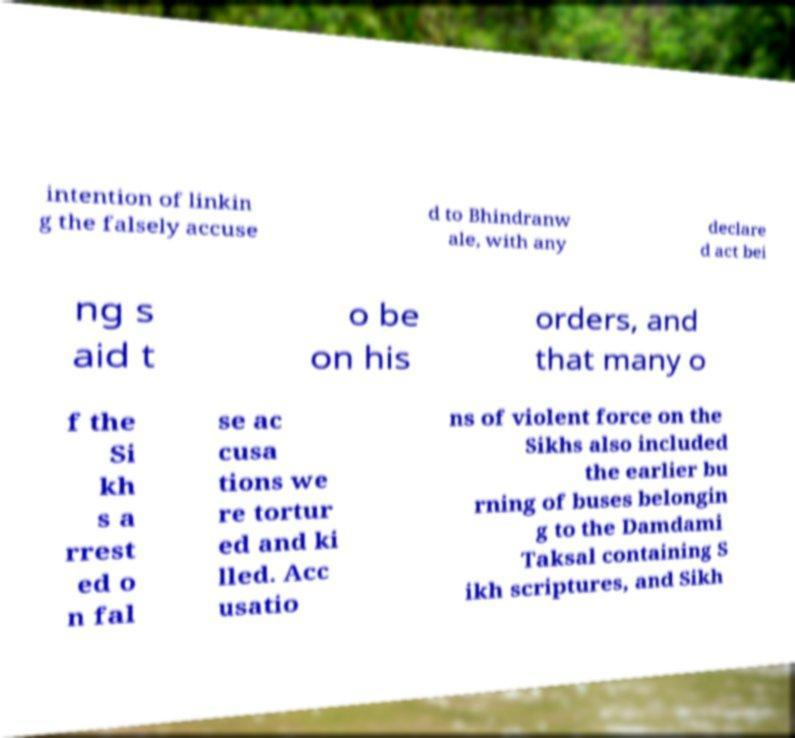Please read and relay the text visible in this image. What does it say? intention of linkin g the falsely accuse d to Bhindranw ale, with any declare d act bei ng s aid t o be on his orders, and that many o f the Si kh s a rrest ed o n fal se ac cusa tions we re tortur ed and ki lled. Acc usatio ns of violent force on the Sikhs also included the earlier bu rning of buses belongin g to the Damdami Taksal containing S ikh scriptures, and Sikh 